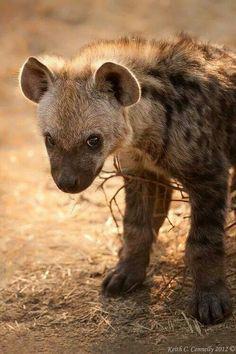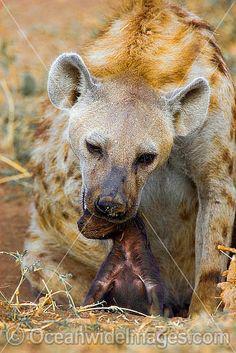The first image is the image on the left, the second image is the image on the right. Assess this claim about the two images: "Some teeth are visible in one of the images.". Correct or not? Answer yes or no. No. 